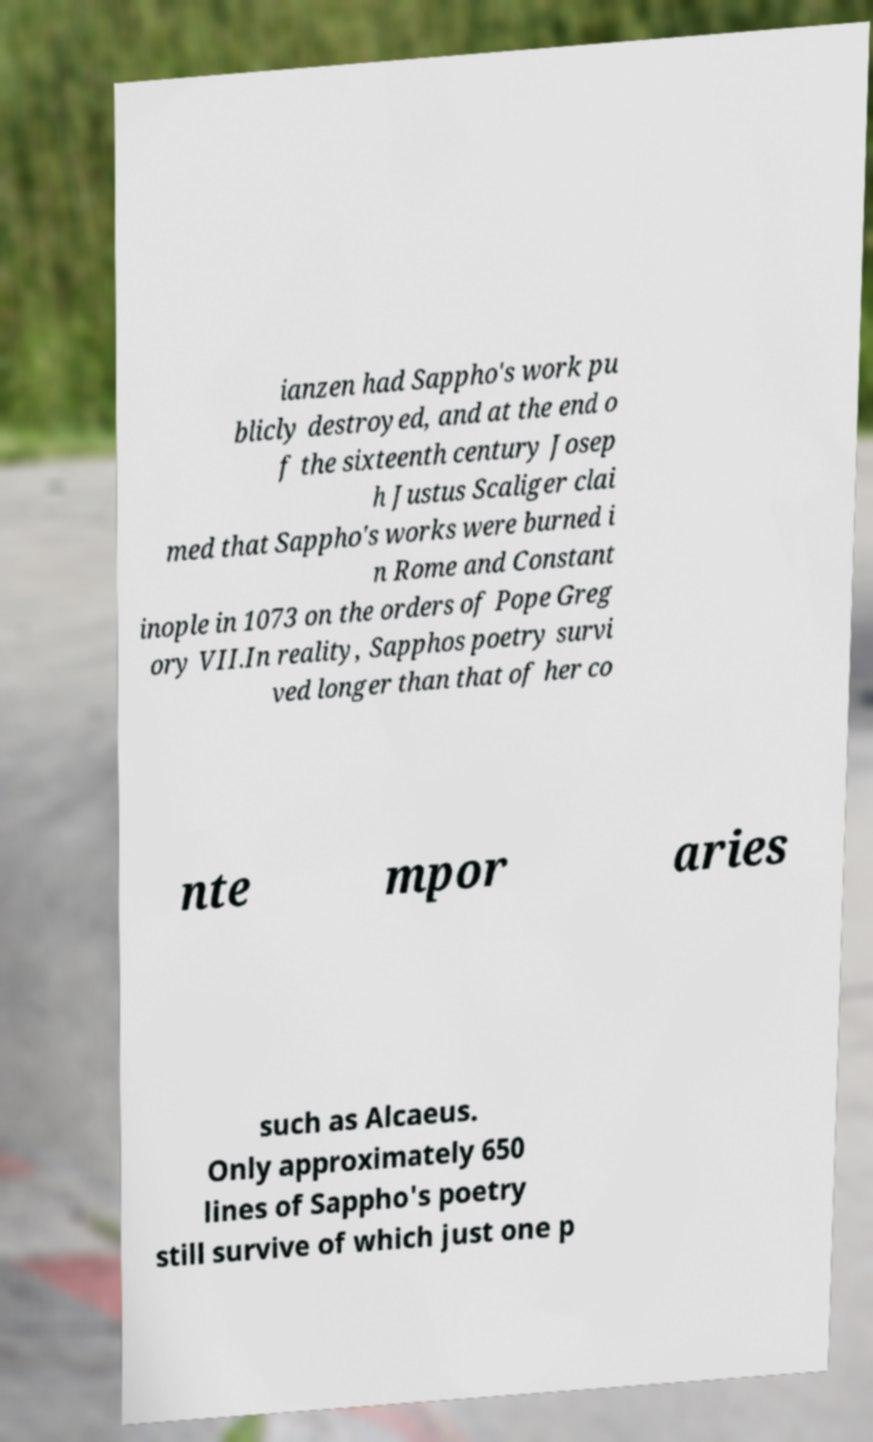Please read and relay the text visible in this image. What does it say? ianzen had Sappho's work pu blicly destroyed, and at the end o f the sixteenth century Josep h Justus Scaliger clai med that Sappho's works were burned i n Rome and Constant inople in 1073 on the orders of Pope Greg ory VII.In reality, Sapphos poetry survi ved longer than that of her co nte mpor aries such as Alcaeus. Only approximately 650 lines of Sappho's poetry still survive of which just one p 